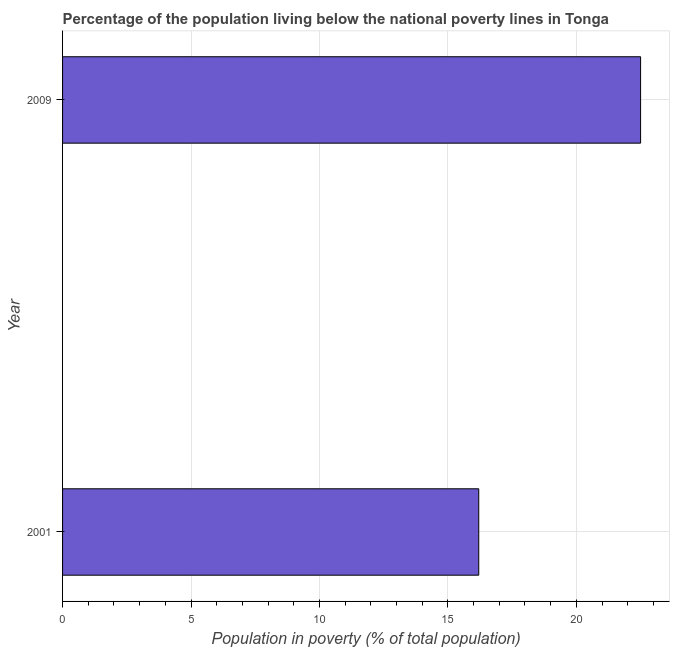What is the title of the graph?
Keep it short and to the point. Percentage of the population living below the national poverty lines in Tonga. What is the label or title of the X-axis?
Ensure brevity in your answer.  Population in poverty (% of total population). What is the percentage of population living below poverty line in 2009?
Provide a short and direct response. 22.5. In which year was the percentage of population living below poverty line maximum?
Provide a short and direct response. 2009. What is the sum of the percentage of population living below poverty line?
Your response must be concise. 38.7. What is the average percentage of population living below poverty line per year?
Your response must be concise. 19.35. What is the median percentage of population living below poverty line?
Your answer should be compact. 19.35. In how many years, is the percentage of population living below poverty line greater than 8 %?
Your answer should be compact. 2. Do a majority of the years between 2001 and 2009 (inclusive) have percentage of population living below poverty line greater than 9 %?
Provide a succinct answer. Yes. What is the ratio of the percentage of population living below poverty line in 2001 to that in 2009?
Your answer should be very brief. 0.72. Is the percentage of population living below poverty line in 2001 less than that in 2009?
Your answer should be compact. Yes. In how many years, is the percentage of population living below poverty line greater than the average percentage of population living below poverty line taken over all years?
Make the answer very short. 1. How many years are there in the graph?
Ensure brevity in your answer.  2. Are the values on the major ticks of X-axis written in scientific E-notation?
Provide a short and direct response. No. What is the Population in poverty (% of total population) in 2009?
Give a very brief answer. 22.5. What is the difference between the Population in poverty (% of total population) in 2001 and 2009?
Keep it short and to the point. -6.3. What is the ratio of the Population in poverty (% of total population) in 2001 to that in 2009?
Provide a succinct answer. 0.72. 